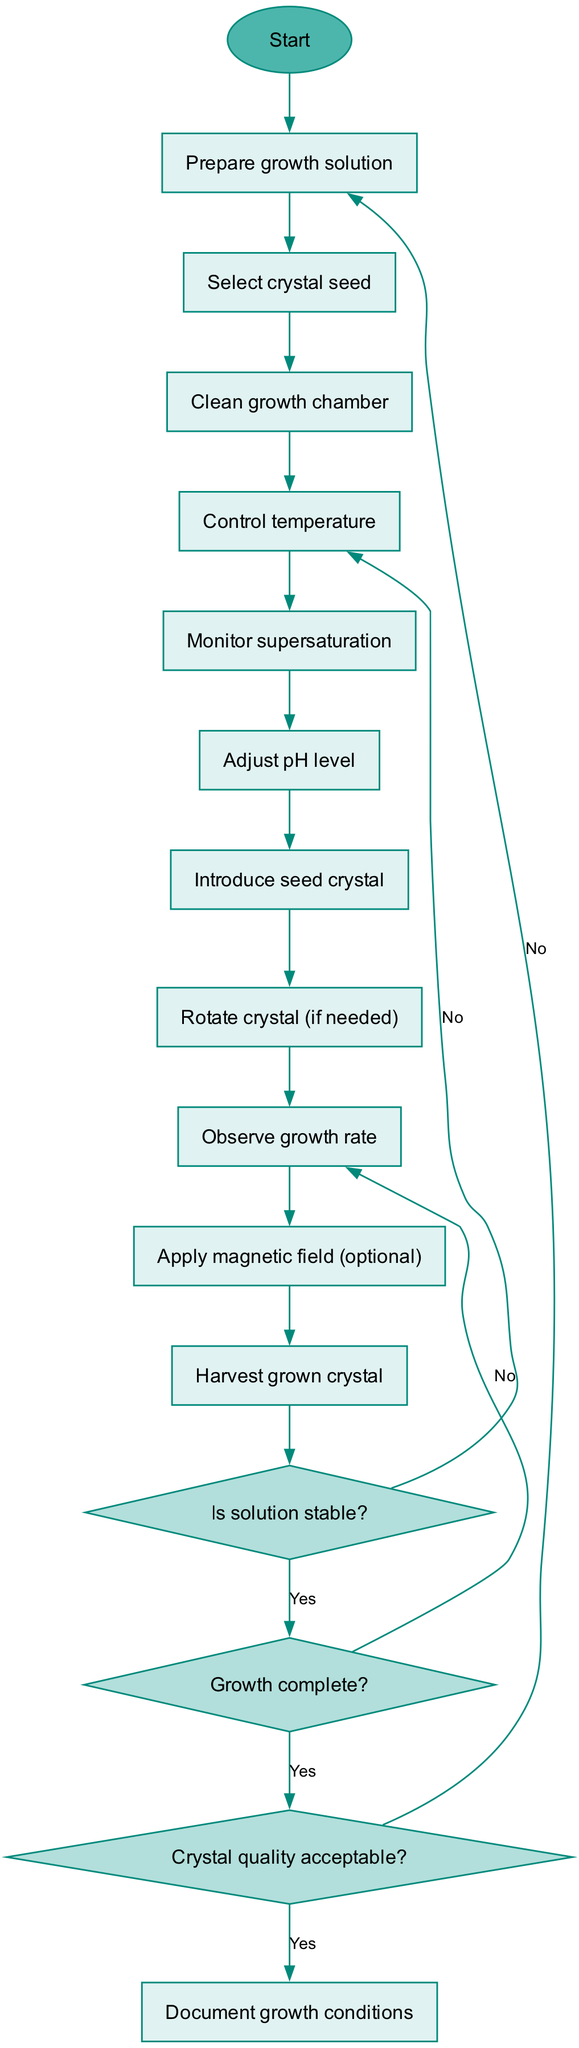What is the initial step in the crystal growth process? The diagram starts with the "Prepare growth solution" node, which is the first activity indicated. This is the initial step before any other actions are taken in the process.
Answer: Prepare growth solution How many activities are depicted in the diagram? By counting the activities listed in the flow, we can identify that there are ten activities in total. This includes all actions taken after the preparation of the growth solution.
Answer: 10 What decision is made after monitoring supersaturation? Following the "Monitor supersaturation" activity, the decision made is to determine "Is solution stable?". This is crucial to evaluate stability before proceeding further.
Answer: Is solution stable? If the growth is not complete, which activity follows? When the decision node "Growth complete?" yields a "No", the flow leads back to "Observe growth rate", indicating that more observation and possibly adjustment are required before completing growth.
Answer: Observe growth rate What happens if the crystal quality is not acceptable? If the decision about crystal quality leads to "No", the process restarts, as indicated in the flow to the "initial" node. This suggests a need to redo parts of the process to improve quality.
Answer: Restart process What is the final output of the diagram? The endpoint of the activity diagram is the final node labeled "Document growth conditions", which signifies the conclusion after the crystal growth and quality assessment. This captures all necessary documentation.
Answer: Document growth conditions What is the relationship between "Monitor supersaturation" and "Introduce seed crystal"? After monitoring supersaturation, if the solution is stable ("Yes" response), the next step in the flow is to "Introduce seed crystal", highlighting the sequential relationship and dependence on solution stability.
Answer: Introduce seed crystal What decision leads to optimizing parameters? The decision "Is solution stable?" results in an "No" response, which then directs the process to "Optimize parameters". This emphasizes the role of solution stability in determining whether further adjustments are needed.
Answer: Optimize parameters What are the possible actions after introducing the seed crystal? After "Introduce seed crystal," the next possible actions could be "Rotate crystal (if needed)" or "Observe growth rate", which are both contingent upon the introduction of the seed crystal for successful growth adaptation.
Answer: Rotate crystal (if needed) / Observe growth rate 